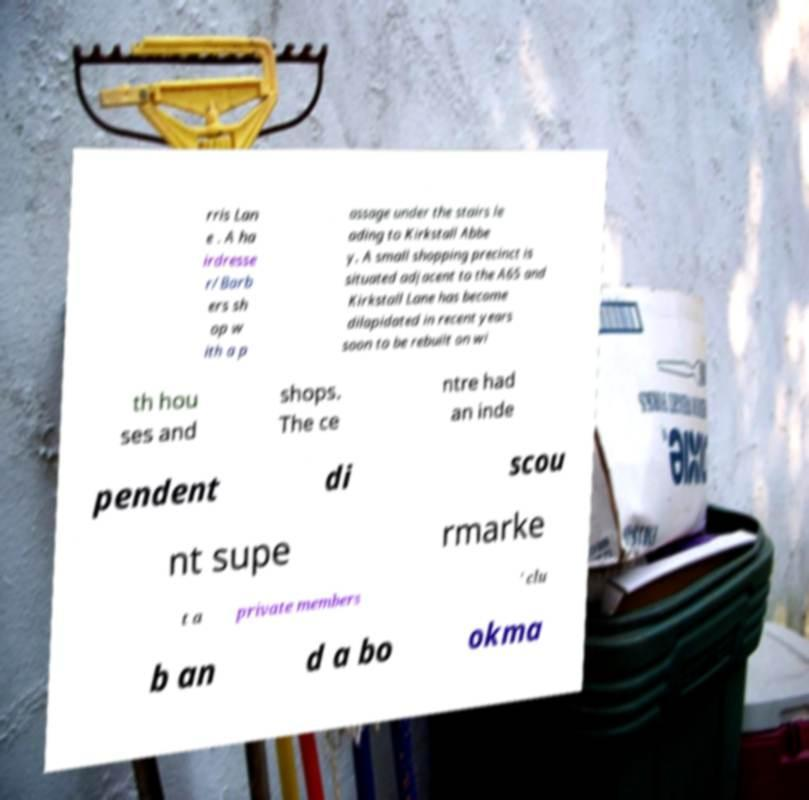Please read and relay the text visible in this image. What does it say? rris Lan e . A ha irdresse r/Barb ers sh op w ith a p assage under the stairs le ading to Kirkstall Abbe y. A small shopping precinct is situated adjacent to the A65 and Kirkstall Lane has become dilapidated in recent years soon to be rebuilt on wi th hou ses and shops. The ce ntre had an inde pendent di scou nt supe rmarke t a private members ' clu b an d a bo okma 